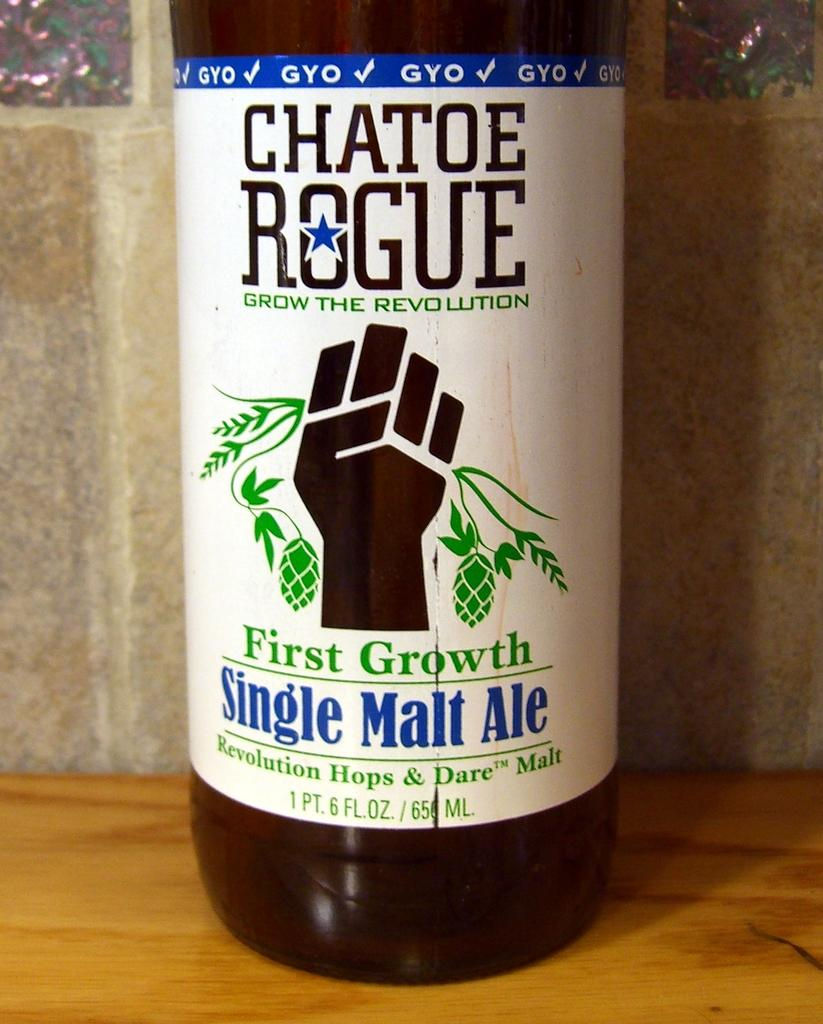Provide a one-sentence caption for the provided image. A closeup of the label for Chatoe Rogue First Growth Single Malt Ale. 